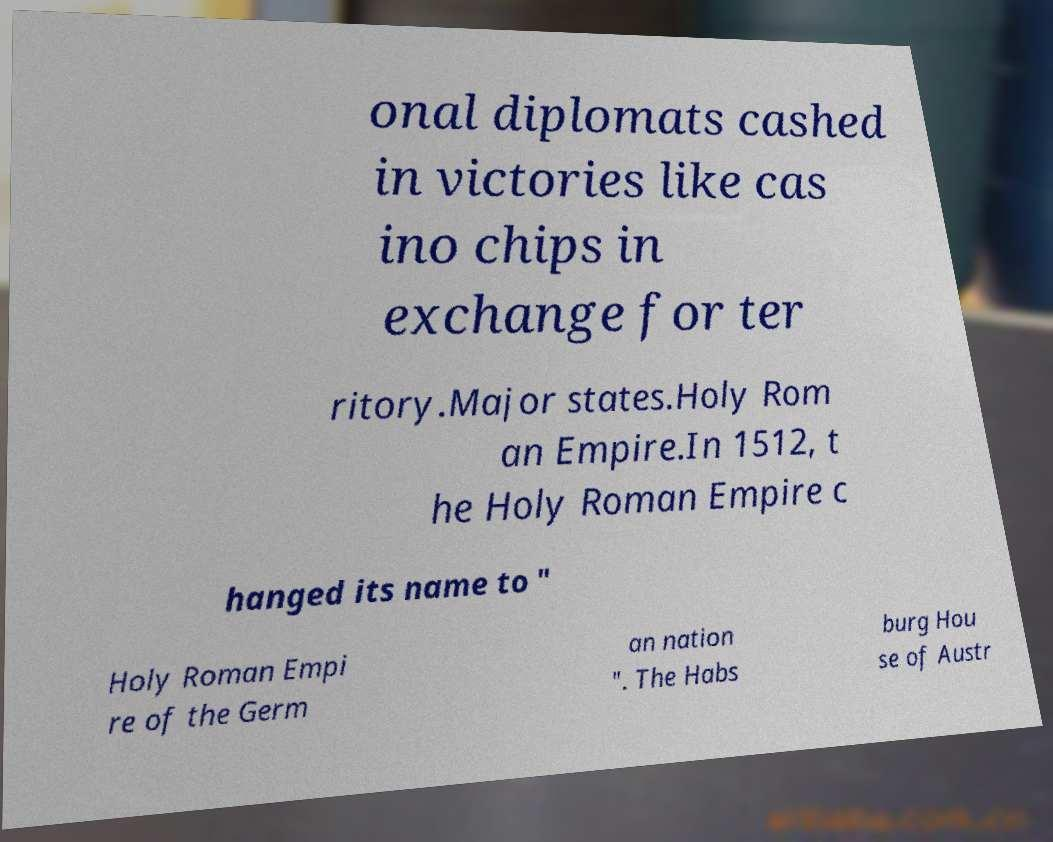For documentation purposes, I need the text within this image transcribed. Could you provide that? onal diplomats cashed in victories like cas ino chips in exchange for ter ritory.Major states.Holy Rom an Empire.In 1512, t he Holy Roman Empire c hanged its name to " Holy Roman Empi re of the Germ an nation ". The Habs burg Hou se of Austr 